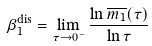Convert formula to latex. <formula><loc_0><loc_0><loc_500><loc_500>\beta _ { 1 } ^ { \text {dis} } = \lim _ { \tau \to 0 ^ { - } } \frac { \ln \overline { m _ { 1 } } ( \tau ) } { \ln \tau }</formula> 